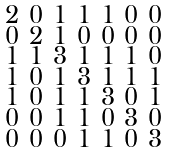<formula> <loc_0><loc_0><loc_500><loc_500>\begin{smallmatrix} 2 & 0 & 1 & 1 & 1 & 0 & 0 \\ 0 & 2 & 1 & 0 & 0 & 0 & 0 \\ 1 & 1 & 3 & 1 & 1 & 1 & 0 \\ 1 & 0 & 1 & 3 & 1 & 1 & 1 \\ 1 & 0 & 1 & 1 & 3 & 0 & 1 \\ 0 & 0 & 1 & 1 & 0 & 3 & 0 \\ 0 & 0 & 0 & 1 & 1 & 0 & 3 \end{smallmatrix}</formula> 